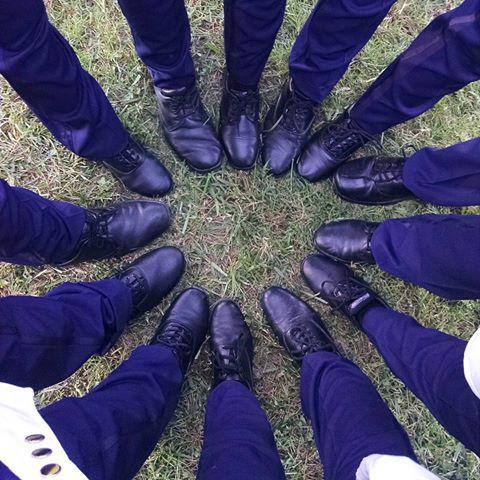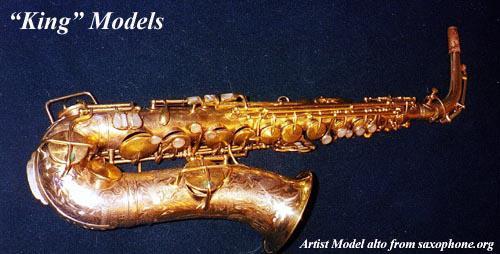The first image is the image on the left, the second image is the image on the right. Given the left and right images, does the statement "There is an image of a saxophone with its neck removed from the body of the instrument." hold true? Answer yes or no. No. 